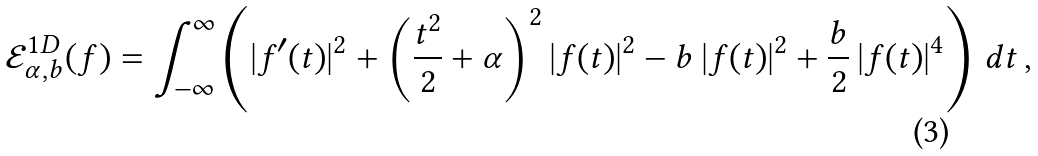<formula> <loc_0><loc_0><loc_500><loc_500>\mathcal { E } ^ { 1 D } _ { \alpha , b } ( f ) = \int _ { - \infty } ^ { \infty } \left ( | f ^ { \prime } ( t ) | ^ { 2 } + \left ( \frac { t ^ { 2 } } 2 + \alpha \right ) ^ { 2 } | f ( t ) | ^ { 2 } - b \, | f ( t ) | ^ { 2 } + \frac { b } 2 \, | f ( t ) | ^ { 4 } \right ) \, d t \, ,</formula> 